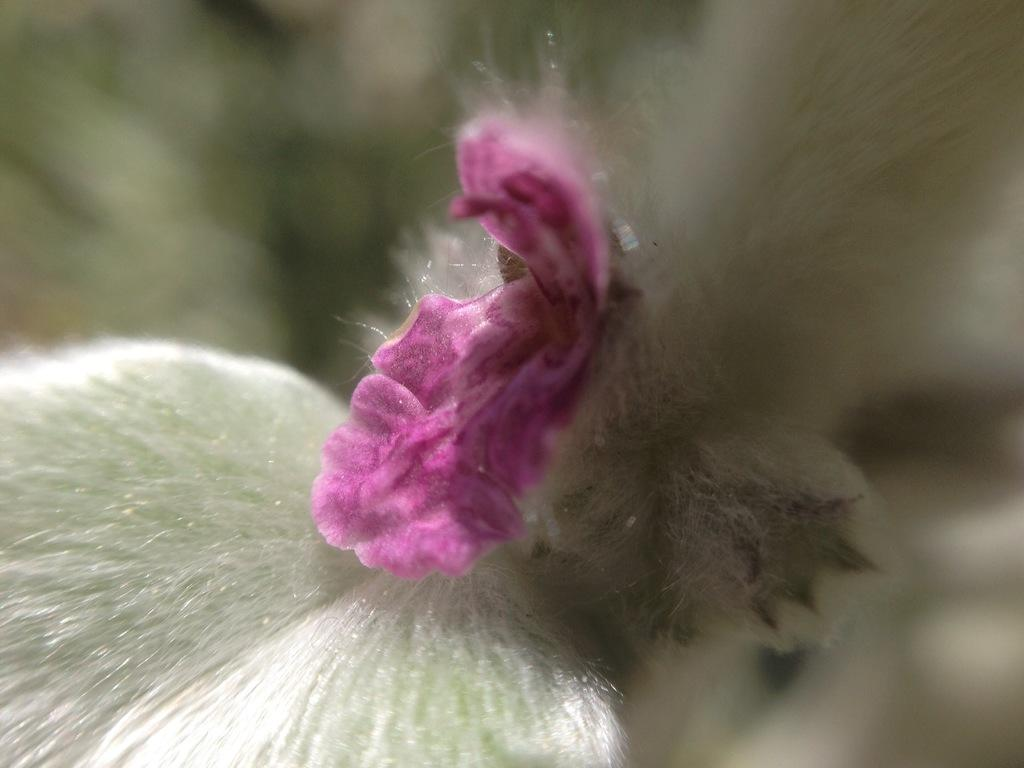What is the color of the object or item in the image? The object or item in the image has a pink and white color. Can you describe the object or item's position in the image? The object or item is blurred in the background. What type of event is happening in the image? There is no event happening in the image; it only features a blurred pink and white object or item in the background. Can you tell me how many knees are visible in the image? There are no knees visible in the image; it only features a blurred pink and white object or item in the background. 